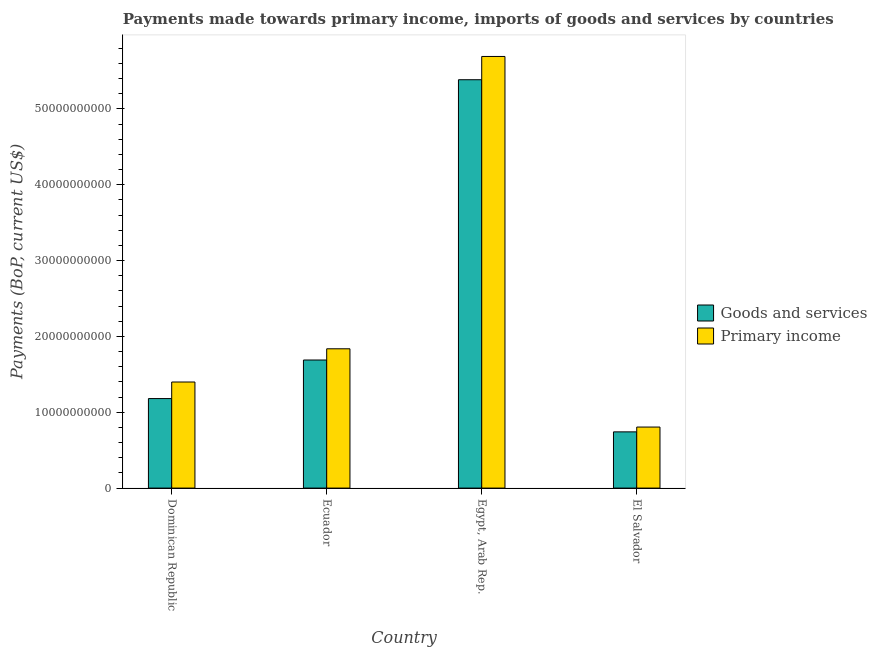How many different coloured bars are there?
Your answer should be very brief. 2. Are the number of bars per tick equal to the number of legend labels?
Offer a terse response. Yes. Are the number of bars on each tick of the X-axis equal?
Give a very brief answer. Yes. What is the label of the 3rd group of bars from the left?
Make the answer very short. Egypt, Arab Rep. What is the payments made towards primary income in Dominican Republic?
Provide a succinct answer. 1.40e+1. Across all countries, what is the maximum payments made towards primary income?
Provide a short and direct response. 5.69e+1. Across all countries, what is the minimum payments made towards primary income?
Offer a terse response. 8.05e+09. In which country was the payments made towards goods and services maximum?
Provide a short and direct response. Egypt, Arab Rep. In which country was the payments made towards primary income minimum?
Give a very brief answer. El Salvador. What is the total payments made towards primary income in the graph?
Keep it short and to the point. 9.73e+1. What is the difference between the payments made towards goods and services in Dominican Republic and that in El Salvador?
Provide a succinct answer. 4.39e+09. What is the difference between the payments made towards goods and services in Ecuador and the payments made towards primary income in Egypt, Arab Rep.?
Ensure brevity in your answer.  -4.00e+1. What is the average payments made towards goods and services per country?
Provide a short and direct response. 2.25e+1. What is the difference between the payments made towards goods and services and payments made towards primary income in Dominican Republic?
Provide a succinct answer. -2.18e+09. What is the ratio of the payments made towards goods and services in Ecuador to that in El Salvador?
Keep it short and to the point. 2.28. What is the difference between the highest and the second highest payments made towards goods and services?
Your answer should be very brief. 3.70e+1. What is the difference between the highest and the lowest payments made towards goods and services?
Make the answer very short. 4.64e+1. What does the 2nd bar from the left in Ecuador represents?
Offer a very short reply. Primary income. What does the 1st bar from the right in Ecuador represents?
Ensure brevity in your answer.  Primary income. How many bars are there?
Ensure brevity in your answer.  8. What is the difference between two consecutive major ticks on the Y-axis?
Your answer should be compact. 1.00e+1. Are the values on the major ticks of Y-axis written in scientific E-notation?
Offer a very short reply. No. Does the graph contain any zero values?
Offer a very short reply. No. Where does the legend appear in the graph?
Your response must be concise. Center right. How many legend labels are there?
Your answer should be very brief. 2. How are the legend labels stacked?
Provide a succinct answer. Vertical. What is the title of the graph?
Offer a terse response. Payments made towards primary income, imports of goods and services by countries. What is the label or title of the X-axis?
Your response must be concise. Country. What is the label or title of the Y-axis?
Provide a succinct answer. Payments (BoP, current US$). What is the Payments (BoP, current US$) in Goods and services in Dominican Republic?
Your answer should be compact. 1.18e+1. What is the Payments (BoP, current US$) of Primary income in Dominican Republic?
Your answer should be very brief. 1.40e+1. What is the Payments (BoP, current US$) of Goods and services in Ecuador?
Your answer should be very brief. 1.69e+1. What is the Payments (BoP, current US$) in Primary income in Ecuador?
Ensure brevity in your answer.  1.84e+1. What is the Payments (BoP, current US$) in Goods and services in Egypt, Arab Rep.?
Your response must be concise. 5.38e+1. What is the Payments (BoP, current US$) of Primary income in Egypt, Arab Rep.?
Your response must be concise. 5.69e+1. What is the Payments (BoP, current US$) in Goods and services in El Salvador?
Offer a terse response. 7.41e+09. What is the Payments (BoP, current US$) of Primary income in El Salvador?
Provide a short and direct response. 8.05e+09. Across all countries, what is the maximum Payments (BoP, current US$) in Goods and services?
Your answer should be very brief. 5.38e+1. Across all countries, what is the maximum Payments (BoP, current US$) of Primary income?
Provide a short and direct response. 5.69e+1. Across all countries, what is the minimum Payments (BoP, current US$) of Goods and services?
Keep it short and to the point. 7.41e+09. Across all countries, what is the minimum Payments (BoP, current US$) of Primary income?
Keep it short and to the point. 8.05e+09. What is the total Payments (BoP, current US$) in Goods and services in the graph?
Your response must be concise. 8.99e+1. What is the total Payments (BoP, current US$) of Primary income in the graph?
Your answer should be compact. 9.73e+1. What is the difference between the Payments (BoP, current US$) of Goods and services in Dominican Republic and that in Ecuador?
Your answer should be very brief. -5.08e+09. What is the difference between the Payments (BoP, current US$) of Primary income in Dominican Republic and that in Ecuador?
Make the answer very short. -4.38e+09. What is the difference between the Payments (BoP, current US$) of Goods and services in Dominican Republic and that in Egypt, Arab Rep.?
Make the answer very short. -4.20e+1. What is the difference between the Payments (BoP, current US$) of Primary income in Dominican Republic and that in Egypt, Arab Rep.?
Keep it short and to the point. -4.29e+1. What is the difference between the Payments (BoP, current US$) of Goods and services in Dominican Republic and that in El Salvador?
Offer a terse response. 4.39e+09. What is the difference between the Payments (BoP, current US$) in Primary income in Dominican Republic and that in El Salvador?
Ensure brevity in your answer.  5.94e+09. What is the difference between the Payments (BoP, current US$) of Goods and services in Ecuador and that in Egypt, Arab Rep.?
Ensure brevity in your answer.  -3.70e+1. What is the difference between the Payments (BoP, current US$) in Primary income in Ecuador and that in Egypt, Arab Rep.?
Your answer should be compact. -3.85e+1. What is the difference between the Payments (BoP, current US$) in Goods and services in Ecuador and that in El Salvador?
Your answer should be very brief. 9.47e+09. What is the difference between the Payments (BoP, current US$) in Primary income in Ecuador and that in El Salvador?
Give a very brief answer. 1.03e+1. What is the difference between the Payments (BoP, current US$) in Goods and services in Egypt, Arab Rep. and that in El Salvador?
Provide a succinct answer. 4.64e+1. What is the difference between the Payments (BoP, current US$) in Primary income in Egypt, Arab Rep. and that in El Salvador?
Your response must be concise. 4.89e+1. What is the difference between the Payments (BoP, current US$) in Goods and services in Dominican Republic and the Payments (BoP, current US$) in Primary income in Ecuador?
Your answer should be compact. -6.56e+09. What is the difference between the Payments (BoP, current US$) in Goods and services in Dominican Republic and the Payments (BoP, current US$) in Primary income in Egypt, Arab Rep.?
Provide a short and direct response. -4.51e+1. What is the difference between the Payments (BoP, current US$) of Goods and services in Dominican Republic and the Payments (BoP, current US$) of Primary income in El Salvador?
Your answer should be very brief. 3.76e+09. What is the difference between the Payments (BoP, current US$) of Goods and services in Ecuador and the Payments (BoP, current US$) of Primary income in Egypt, Arab Rep.?
Ensure brevity in your answer.  -4.00e+1. What is the difference between the Payments (BoP, current US$) of Goods and services in Ecuador and the Payments (BoP, current US$) of Primary income in El Salvador?
Provide a succinct answer. 8.84e+09. What is the difference between the Payments (BoP, current US$) in Goods and services in Egypt, Arab Rep. and the Payments (BoP, current US$) in Primary income in El Salvador?
Your answer should be compact. 4.58e+1. What is the average Payments (BoP, current US$) of Goods and services per country?
Offer a very short reply. 2.25e+1. What is the average Payments (BoP, current US$) in Primary income per country?
Offer a very short reply. 2.43e+1. What is the difference between the Payments (BoP, current US$) in Goods and services and Payments (BoP, current US$) in Primary income in Dominican Republic?
Your response must be concise. -2.18e+09. What is the difference between the Payments (BoP, current US$) in Goods and services and Payments (BoP, current US$) in Primary income in Ecuador?
Ensure brevity in your answer.  -1.48e+09. What is the difference between the Payments (BoP, current US$) of Goods and services and Payments (BoP, current US$) of Primary income in Egypt, Arab Rep.?
Offer a very short reply. -3.07e+09. What is the difference between the Payments (BoP, current US$) in Goods and services and Payments (BoP, current US$) in Primary income in El Salvador?
Offer a very short reply. -6.33e+08. What is the ratio of the Payments (BoP, current US$) in Goods and services in Dominican Republic to that in Ecuador?
Make the answer very short. 0.7. What is the ratio of the Payments (BoP, current US$) of Primary income in Dominican Republic to that in Ecuador?
Offer a terse response. 0.76. What is the ratio of the Payments (BoP, current US$) in Goods and services in Dominican Republic to that in Egypt, Arab Rep.?
Give a very brief answer. 0.22. What is the ratio of the Payments (BoP, current US$) in Primary income in Dominican Republic to that in Egypt, Arab Rep.?
Your answer should be compact. 0.25. What is the ratio of the Payments (BoP, current US$) in Goods and services in Dominican Republic to that in El Salvador?
Keep it short and to the point. 1.59. What is the ratio of the Payments (BoP, current US$) in Primary income in Dominican Republic to that in El Salvador?
Your answer should be very brief. 1.74. What is the ratio of the Payments (BoP, current US$) of Goods and services in Ecuador to that in Egypt, Arab Rep.?
Your answer should be compact. 0.31. What is the ratio of the Payments (BoP, current US$) of Primary income in Ecuador to that in Egypt, Arab Rep.?
Your answer should be compact. 0.32. What is the ratio of the Payments (BoP, current US$) in Goods and services in Ecuador to that in El Salvador?
Give a very brief answer. 2.28. What is the ratio of the Payments (BoP, current US$) in Primary income in Ecuador to that in El Salvador?
Make the answer very short. 2.28. What is the ratio of the Payments (BoP, current US$) of Goods and services in Egypt, Arab Rep. to that in El Salvador?
Provide a succinct answer. 7.26. What is the ratio of the Payments (BoP, current US$) in Primary income in Egypt, Arab Rep. to that in El Salvador?
Ensure brevity in your answer.  7.07. What is the difference between the highest and the second highest Payments (BoP, current US$) of Goods and services?
Offer a terse response. 3.70e+1. What is the difference between the highest and the second highest Payments (BoP, current US$) of Primary income?
Your answer should be very brief. 3.85e+1. What is the difference between the highest and the lowest Payments (BoP, current US$) in Goods and services?
Provide a succinct answer. 4.64e+1. What is the difference between the highest and the lowest Payments (BoP, current US$) in Primary income?
Offer a terse response. 4.89e+1. 